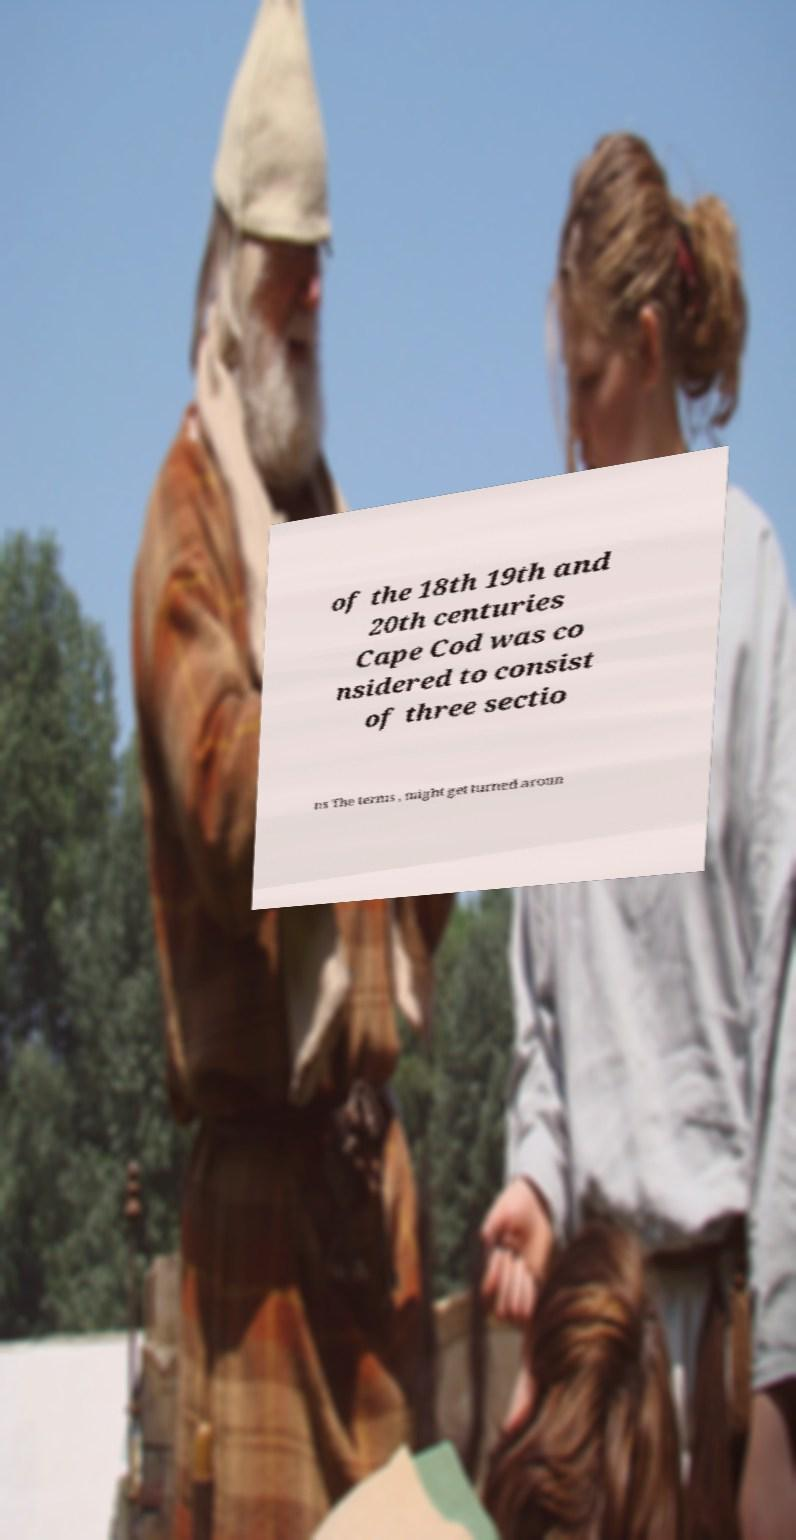Can you read and provide the text displayed in the image?This photo seems to have some interesting text. Can you extract and type it out for me? of the 18th 19th and 20th centuries Cape Cod was co nsidered to consist of three sectio ns The terms , might get turned aroun 